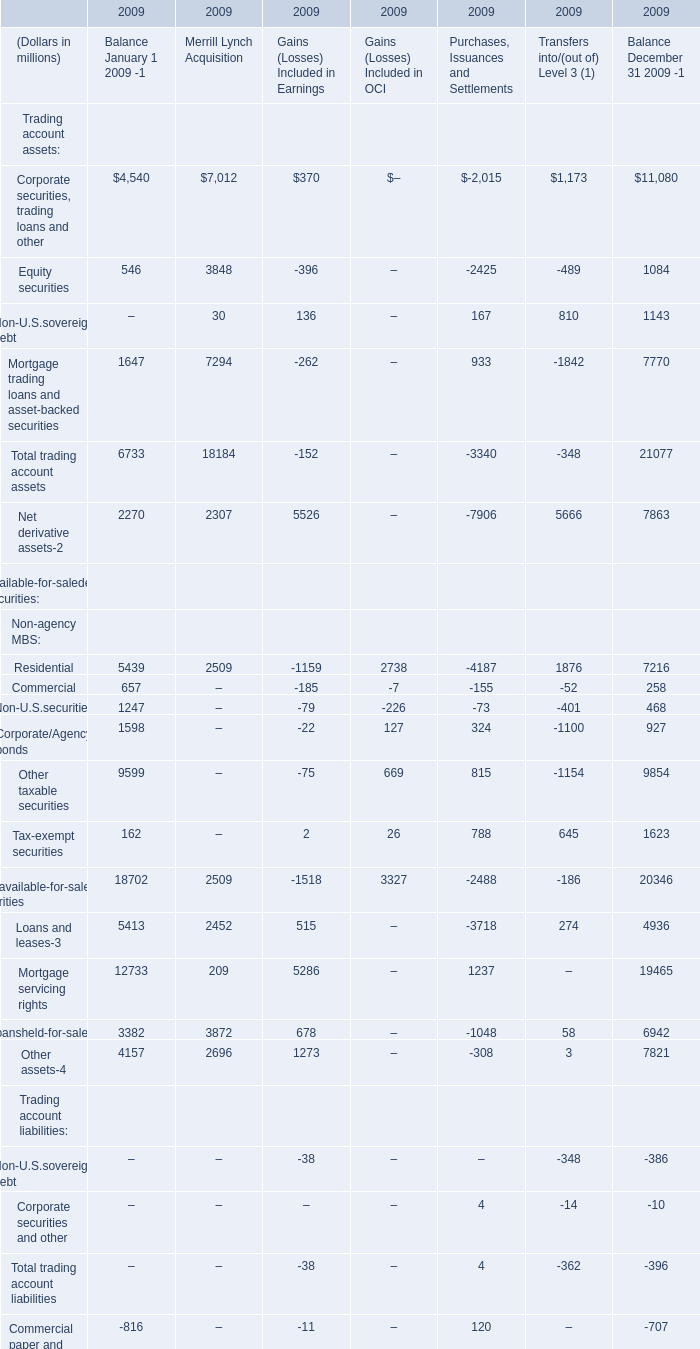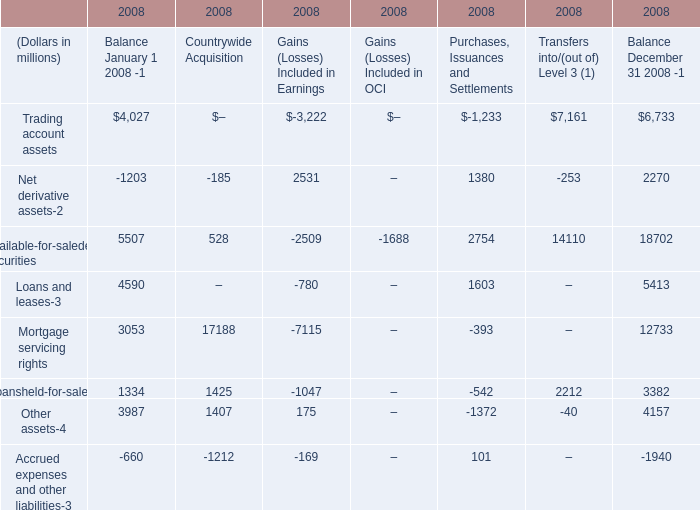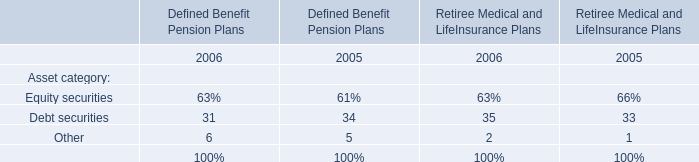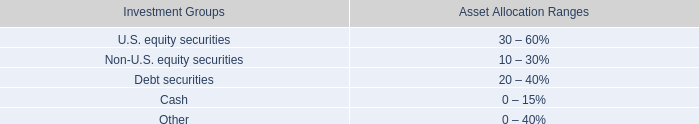How many Trading account assets exceed the average of Trading account assets in terms of Balance January 1 2009 in 2009? 
Answer: 1. 